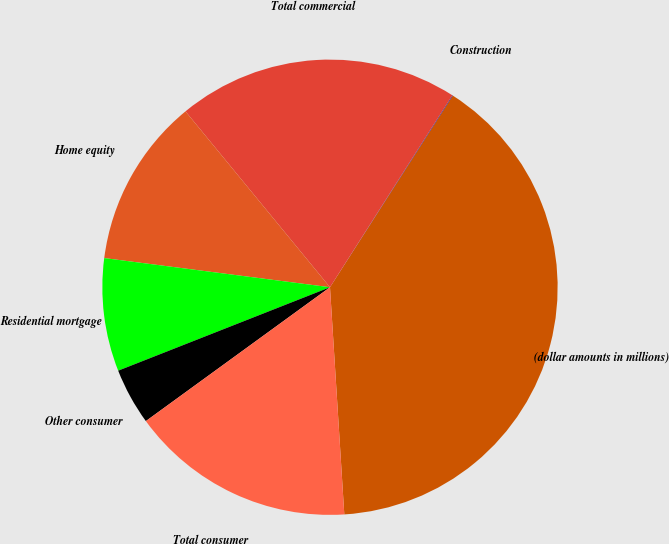<chart> <loc_0><loc_0><loc_500><loc_500><pie_chart><fcel>(dollar amounts in millions)<fcel>Construction<fcel>Total commercial<fcel>Home equity<fcel>Residential mortgage<fcel>Other consumer<fcel>Total consumer<nl><fcel>39.93%<fcel>0.04%<fcel>19.98%<fcel>12.01%<fcel>8.02%<fcel>4.03%<fcel>16.0%<nl></chart> 